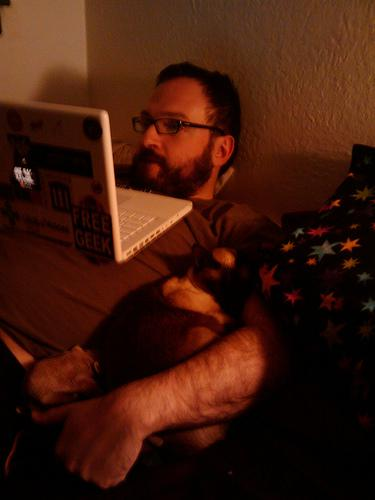Question: where is the computer?
Choices:
A. On the desk.
B. On the table.
C. On the man's chest.
D. On the bed.
Answer with the letter. Answer: C Question: who is holding a computer?
Choices:
A. A woman.
B. A girl.
C. The man.
D. A boy.
Answer with the letter. Answer: C Question: when was the picture taken?
Choices:
A. Afternoon.
B. Morning.
C. Night.
D. Evening.
Answer with the letter. Answer: D 